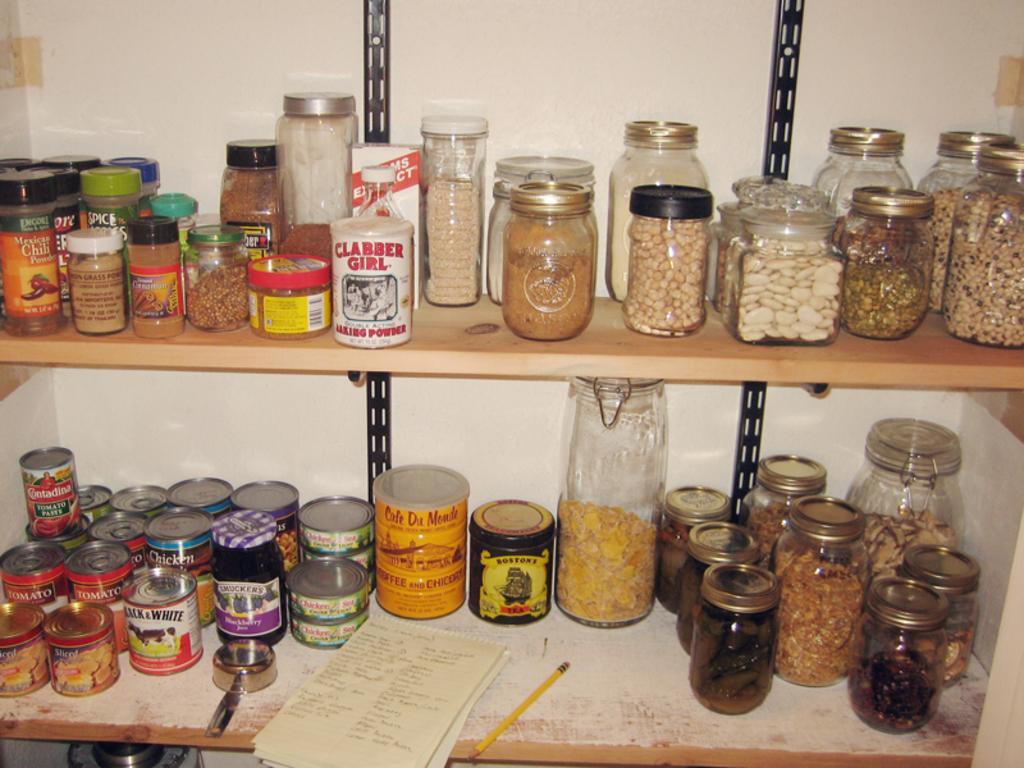Describe this image in one or two sentences. In this picture there are few jars which has some objects placed in it is placed on a wooden shelves. 